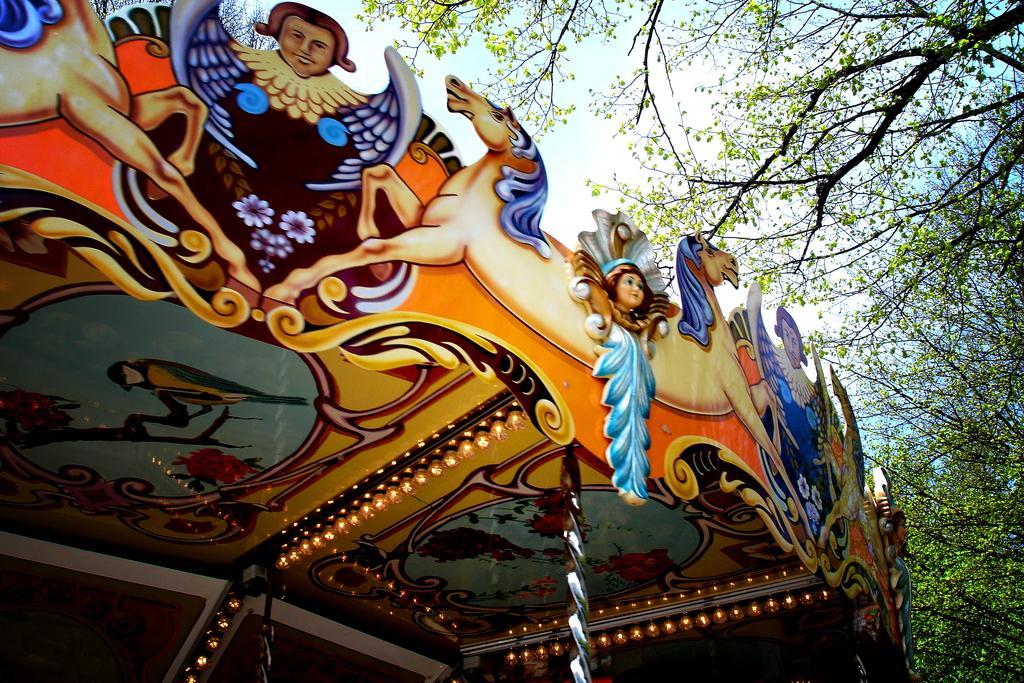In one or two sentences, can you explain what this image depicts? In the image there is a ceiling with colorful lights and paintings on it, on right side there are trees. 